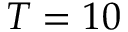Convert formula to latex. <formula><loc_0><loc_0><loc_500><loc_500>T = 1 0</formula> 